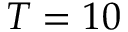Convert formula to latex. <formula><loc_0><loc_0><loc_500><loc_500>T = 1 0</formula> 